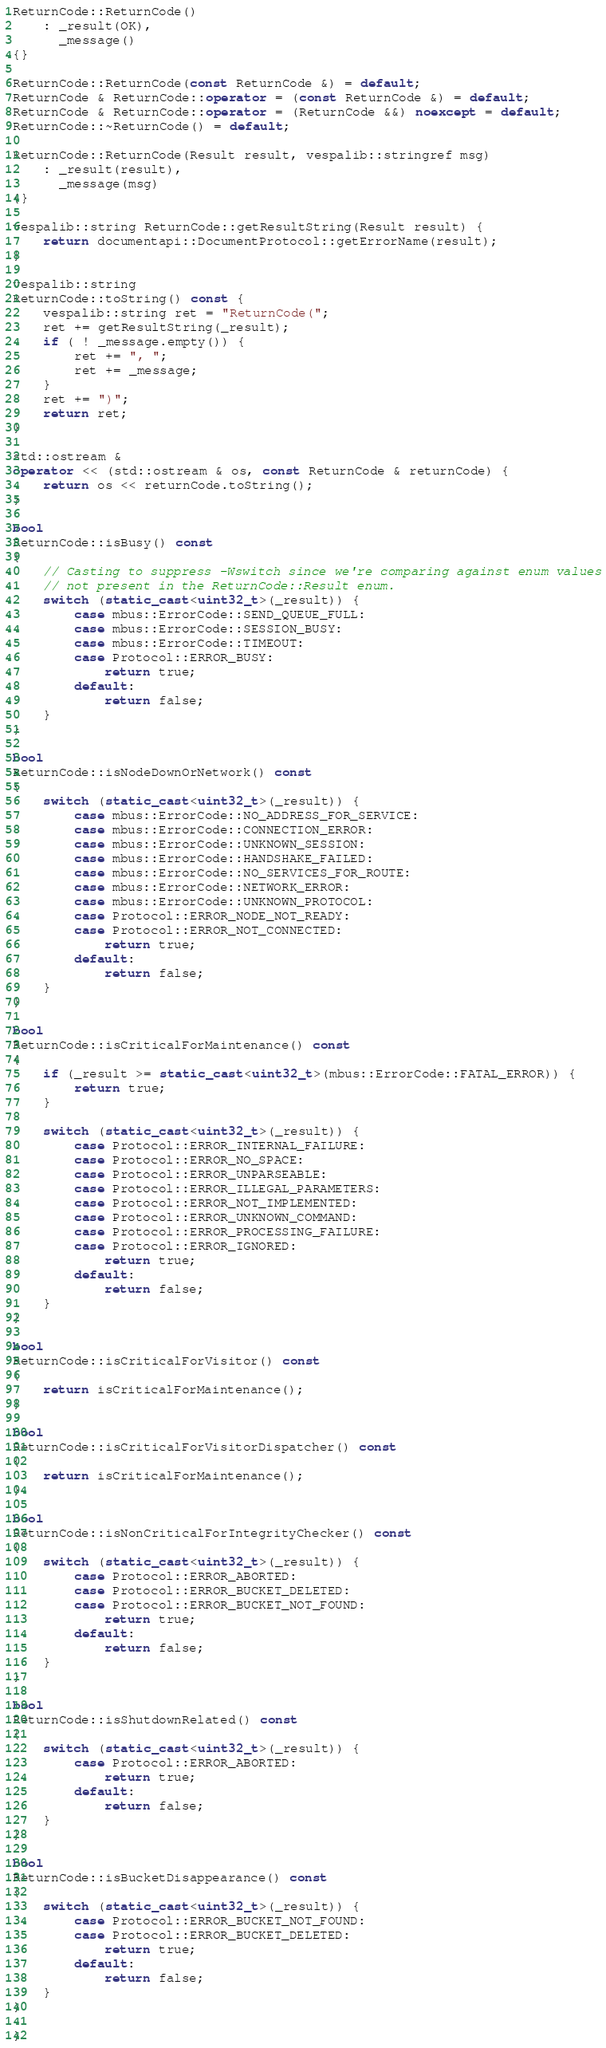<code> <loc_0><loc_0><loc_500><loc_500><_C++_>
ReturnCode::ReturnCode()
    : _result(OK),
      _message()
{}

ReturnCode::ReturnCode(const ReturnCode &) = default;
ReturnCode & ReturnCode::operator = (const ReturnCode &) = default;
ReturnCode & ReturnCode::operator = (ReturnCode &&) noexcept = default;
ReturnCode::~ReturnCode() = default;

ReturnCode::ReturnCode(Result result, vespalib::stringref msg)
    : _result(result),
      _message(msg)
{}

vespalib::string ReturnCode::getResultString(Result result) {
    return documentapi::DocumentProtocol::getErrorName(result);
}

vespalib::string
ReturnCode::toString() const {
    vespalib::string ret = "ReturnCode(";
    ret += getResultString(_result);
    if ( ! _message.empty()) {
        ret += ", ";
        ret += _message;
    }
    ret += ")";
    return ret;
}

std::ostream &
operator << (std::ostream & os, const ReturnCode & returnCode) {
    return os << returnCode.toString();
}

bool
ReturnCode::isBusy() const
{
    // Casting to suppress -Wswitch since we're comparing against enum values
    // not present in the ReturnCode::Result enum.
    switch (static_cast<uint32_t>(_result)) {
        case mbus::ErrorCode::SEND_QUEUE_FULL:
        case mbus::ErrorCode::SESSION_BUSY:
        case mbus::ErrorCode::TIMEOUT:
        case Protocol::ERROR_BUSY:
            return true;
        default:
            return false;
    }
}

bool
ReturnCode::isNodeDownOrNetwork() const
{
    switch (static_cast<uint32_t>(_result)) {
        case mbus::ErrorCode::NO_ADDRESS_FOR_SERVICE:
        case mbus::ErrorCode::CONNECTION_ERROR:
        case mbus::ErrorCode::UNKNOWN_SESSION:
        case mbus::ErrorCode::HANDSHAKE_FAILED:
        case mbus::ErrorCode::NO_SERVICES_FOR_ROUTE:
        case mbus::ErrorCode::NETWORK_ERROR:
        case mbus::ErrorCode::UNKNOWN_PROTOCOL:
        case Protocol::ERROR_NODE_NOT_READY:
        case Protocol::ERROR_NOT_CONNECTED:
            return true;
        default:
            return false;
    }
}

bool
ReturnCode::isCriticalForMaintenance() const
{
    if (_result >= static_cast<uint32_t>(mbus::ErrorCode::FATAL_ERROR)) {
        return true;
    }

    switch (static_cast<uint32_t>(_result)) {
        case Protocol::ERROR_INTERNAL_FAILURE:
        case Protocol::ERROR_NO_SPACE:
        case Protocol::ERROR_UNPARSEABLE:
        case Protocol::ERROR_ILLEGAL_PARAMETERS:
        case Protocol::ERROR_NOT_IMPLEMENTED:
        case Protocol::ERROR_UNKNOWN_COMMAND:
        case Protocol::ERROR_PROCESSING_FAILURE:
        case Protocol::ERROR_IGNORED:
            return true;
        default:
            return false;
    }
}

bool
ReturnCode::isCriticalForVisitor() const
{
    return isCriticalForMaintenance();
}

bool
ReturnCode::isCriticalForVisitorDispatcher() const
{
    return isCriticalForMaintenance();
}

bool
ReturnCode::isNonCriticalForIntegrityChecker() const
{
    switch (static_cast<uint32_t>(_result)) {
        case Protocol::ERROR_ABORTED:
        case Protocol::ERROR_BUCKET_DELETED:
        case Protocol::ERROR_BUCKET_NOT_FOUND:
            return true;
        default:
            return false;
    }
}

bool
ReturnCode::isShutdownRelated() const
{
    switch (static_cast<uint32_t>(_result)) {
        case Protocol::ERROR_ABORTED:
            return true;
        default:
            return false;
    }
}

bool
ReturnCode::isBucketDisappearance() const
{
    switch (static_cast<uint32_t>(_result)) {
        case Protocol::ERROR_BUCKET_NOT_FOUND:
        case Protocol::ERROR_BUCKET_DELETED:
            return true;
        default:
            return false;
    }
}

}
</code> 